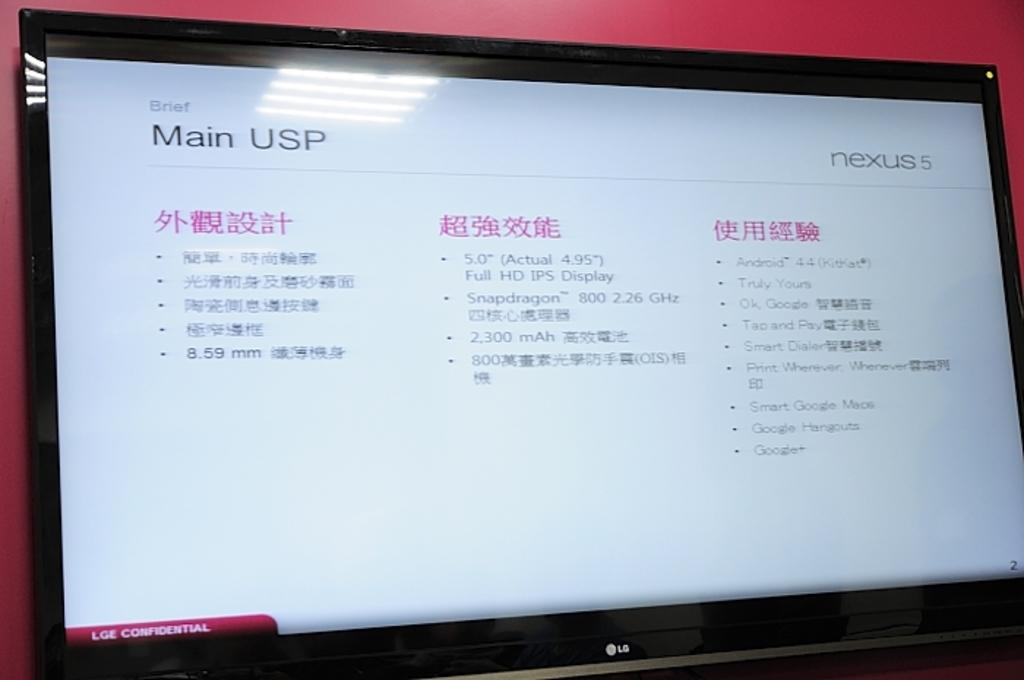<image>
Relay a brief, clear account of the picture shown. a computer screen open to a site for NEXUS 5 Main USP 